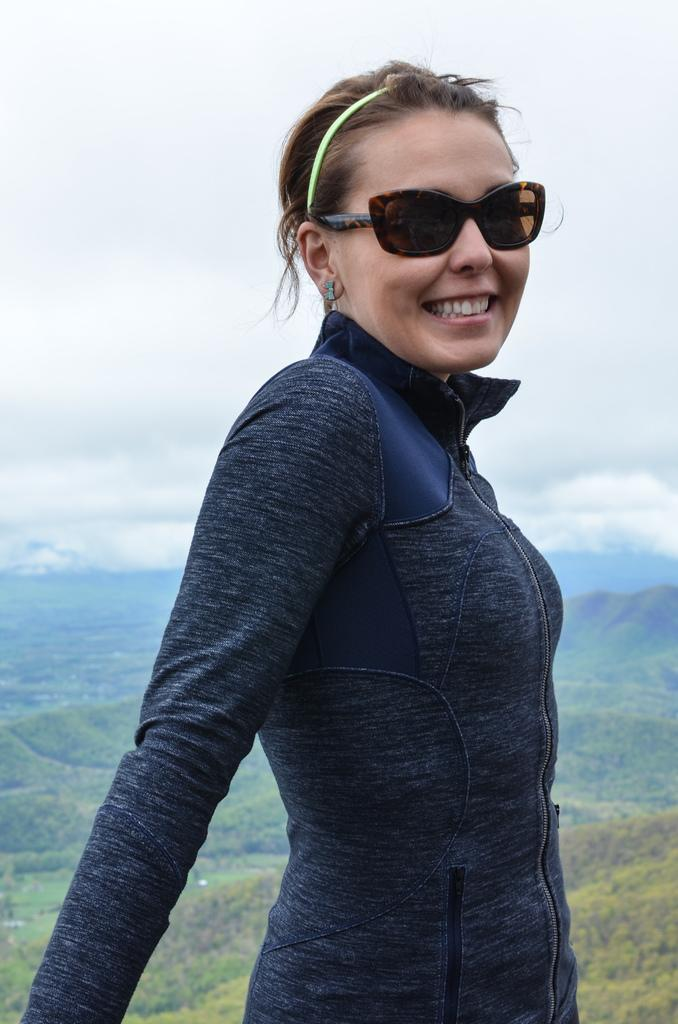Who is present in the image? There is a woman in the image. What is the woman doing in the image? The woman is standing in the image. What is the woman's facial expression in the image? The woman is smiling in the image. What can be seen in the background of the image? There is sky and hills visible in the background of the image. What is the condition of the sky in the image? The sky has clouds in the image. What type of frame surrounds the woman in the image? There is no frame surrounding the woman in the image; it is a photograph or digital image without a frame. 